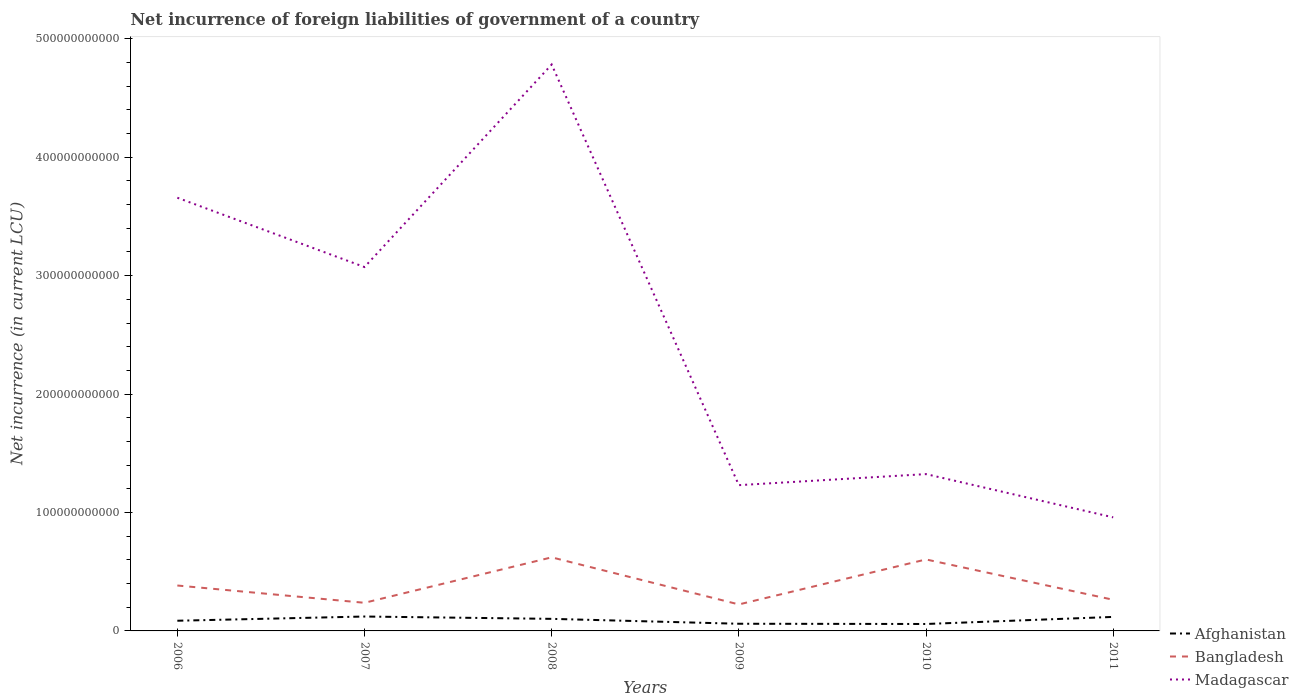Does the line corresponding to Madagascar intersect with the line corresponding to Bangladesh?
Your answer should be compact. No. Across all years, what is the maximum net incurrence of foreign liabilities in Afghanistan?
Offer a terse response. 5.86e+09. What is the total net incurrence of foreign liabilities in Bangladesh in the graph?
Provide a short and direct response. -3.94e+09. What is the difference between the highest and the second highest net incurrence of foreign liabilities in Madagascar?
Offer a terse response. 3.82e+11. How many lines are there?
Offer a terse response. 3. What is the difference between two consecutive major ticks on the Y-axis?
Your answer should be compact. 1.00e+11. Where does the legend appear in the graph?
Your response must be concise. Bottom right. How are the legend labels stacked?
Provide a short and direct response. Vertical. What is the title of the graph?
Ensure brevity in your answer.  Net incurrence of foreign liabilities of government of a country. Does "Uzbekistan" appear as one of the legend labels in the graph?
Your answer should be compact. No. What is the label or title of the X-axis?
Offer a very short reply. Years. What is the label or title of the Y-axis?
Keep it short and to the point. Net incurrence (in current LCU). What is the Net incurrence (in current LCU) of Afghanistan in 2006?
Your answer should be compact. 8.60e+09. What is the Net incurrence (in current LCU) in Bangladesh in 2006?
Your answer should be compact. 3.83e+1. What is the Net incurrence (in current LCU) of Madagascar in 2006?
Provide a succinct answer. 3.66e+11. What is the Net incurrence (in current LCU) in Afghanistan in 2007?
Ensure brevity in your answer.  1.22e+1. What is the Net incurrence (in current LCU) in Bangladesh in 2007?
Offer a terse response. 2.38e+1. What is the Net incurrence (in current LCU) in Madagascar in 2007?
Offer a very short reply. 3.07e+11. What is the Net incurrence (in current LCU) in Afghanistan in 2008?
Offer a terse response. 1.02e+1. What is the Net incurrence (in current LCU) of Bangladesh in 2008?
Offer a very short reply. 6.21e+1. What is the Net incurrence (in current LCU) in Madagascar in 2008?
Offer a very short reply. 4.78e+11. What is the Net incurrence (in current LCU) in Afghanistan in 2009?
Make the answer very short. 6.05e+09. What is the Net incurrence (in current LCU) in Bangladesh in 2009?
Your answer should be compact. 2.24e+1. What is the Net incurrence (in current LCU) of Madagascar in 2009?
Ensure brevity in your answer.  1.23e+11. What is the Net incurrence (in current LCU) of Afghanistan in 2010?
Give a very brief answer. 5.86e+09. What is the Net incurrence (in current LCU) of Bangladesh in 2010?
Provide a succinct answer. 6.04e+1. What is the Net incurrence (in current LCU) in Madagascar in 2010?
Make the answer very short. 1.32e+11. What is the Net incurrence (in current LCU) in Afghanistan in 2011?
Your answer should be compact. 1.18e+1. What is the Net incurrence (in current LCU) in Bangladesh in 2011?
Make the answer very short. 2.63e+1. What is the Net incurrence (in current LCU) of Madagascar in 2011?
Your response must be concise. 9.59e+1. Across all years, what is the maximum Net incurrence (in current LCU) of Afghanistan?
Give a very brief answer. 1.22e+1. Across all years, what is the maximum Net incurrence (in current LCU) in Bangladesh?
Offer a very short reply. 6.21e+1. Across all years, what is the maximum Net incurrence (in current LCU) in Madagascar?
Keep it short and to the point. 4.78e+11. Across all years, what is the minimum Net incurrence (in current LCU) in Afghanistan?
Your answer should be very brief. 5.86e+09. Across all years, what is the minimum Net incurrence (in current LCU) of Bangladesh?
Provide a succinct answer. 2.24e+1. Across all years, what is the minimum Net incurrence (in current LCU) of Madagascar?
Your answer should be compact. 9.59e+1. What is the total Net incurrence (in current LCU) of Afghanistan in the graph?
Your answer should be very brief. 5.47e+1. What is the total Net incurrence (in current LCU) of Bangladesh in the graph?
Your answer should be very brief. 2.33e+11. What is the total Net incurrence (in current LCU) of Madagascar in the graph?
Keep it short and to the point. 1.50e+12. What is the difference between the Net incurrence (in current LCU) of Afghanistan in 2006 and that in 2007?
Ensure brevity in your answer.  -3.56e+09. What is the difference between the Net incurrence (in current LCU) of Bangladesh in 2006 and that in 2007?
Your response must be concise. 1.46e+1. What is the difference between the Net incurrence (in current LCU) in Madagascar in 2006 and that in 2007?
Your response must be concise. 5.85e+1. What is the difference between the Net incurrence (in current LCU) of Afghanistan in 2006 and that in 2008?
Give a very brief answer. -1.59e+09. What is the difference between the Net incurrence (in current LCU) in Bangladesh in 2006 and that in 2008?
Give a very brief answer. -2.38e+1. What is the difference between the Net incurrence (in current LCU) in Madagascar in 2006 and that in 2008?
Your answer should be compact. -1.12e+11. What is the difference between the Net incurrence (in current LCU) of Afghanistan in 2006 and that in 2009?
Your answer should be compact. 2.55e+09. What is the difference between the Net incurrence (in current LCU) in Bangladesh in 2006 and that in 2009?
Make the answer very short. 1.60e+1. What is the difference between the Net incurrence (in current LCU) in Madagascar in 2006 and that in 2009?
Your response must be concise. 2.43e+11. What is the difference between the Net incurrence (in current LCU) in Afghanistan in 2006 and that in 2010?
Make the answer very short. 2.75e+09. What is the difference between the Net incurrence (in current LCU) in Bangladesh in 2006 and that in 2010?
Provide a short and direct response. -2.20e+1. What is the difference between the Net incurrence (in current LCU) in Madagascar in 2006 and that in 2010?
Make the answer very short. 2.33e+11. What is the difference between the Net incurrence (in current LCU) of Afghanistan in 2006 and that in 2011?
Keep it short and to the point. -3.23e+09. What is the difference between the Net incurrence (in current LCU) in Bangladesh in 2006 and that in 2011?
Provide a short and direct response. 1.20e+1. What is the difference between the Net incurrence (in current LCU) in Madagascar in 2006 and that in 2011?
Your answer should be very brief. 2.70e+11. What is the difference between the Net incurrence (in current LCU) in Afghanistan in 2007 and that in 2008?
Provide a succinct answer. 1.97e+09. What is the difference between the Net incurrence (in current LCU) in Bangladesh in 2007 and that in 2008?
Provide a short and direct response. -3.84e+1. What is the difference between the Net incurrence (in current LCU) of Madagascar in 2007 and that in 2008?
Offer a terse response. -1.71e+11. What is the difference between the Net incurrence (in current LCU) in Afghanistan in 2007 and that in 2009?
Offer a terse response. 6.11e+09. What is the difference between the Net incurrence (in current LCU) of Bangladesh in 2007 and that in 2009?
Your answer should be compact. 1.38e+09. What is the difference between the Net incurrence (in current LCU) in Madagascar in 2007 and that in 2009?
Make the answer very short. 1.84e+11. What is the difference between the Net incurrence (in current LCU) in Afghanistan in 2007 and that in 2010?
Your answer should be very brief. 6.31e+09. What is the difference between the Net incurrence (in current LCU) in Bangladesh in 2007 and that in 2010?
Offer a terse response. -3.66e+1. What is the difference between the Net incurrence (in current LCU) in Madagascar in 2007 and that in 2010?
Give a very brief answer. 1.75e+11. What is the difference between the Net incurrence (in current LCU) in Afghanistan in 2007 and that in 2011?
Provide a succinct answer. 3.28e+08. What is the difference between the Net incurrence (in current LCU) in Bangladesh in 2007 and that in 2011?
Offer a very short reply. -2.56e+09. What is the difference between the Net incurrence (in current LCU) of Madagascar in 2007 and that in 2011?
Provide a short and direct response. 2.11e+11. What is the difference between the Net incurrence (in current LCU) of Afghanistan in 2008 and that in 2009?
Your answer should be compact. 4.14e+09. What is the difference between the Net incurrence (in current LCU) in Bangladesh in 2008 and that in 2009?
Offer a terse response. 3.98e+1. What is the difference between the Net incurrence (in current LCU) in Madagascar in 2008 and that in 2009?
Offer a very short reply. 3.55e+11. What is the difference between the Net incurrence (in current LCU) in Afghanistan in 2008 and that in 2010?
Your answer should be very brief. 4.33e+09. What is the difference between the Net incurrence (in current LCU) of Bangladesh in 2008 and that in 2010?
Give a very brief answer. 1.78e+09. What is the difference between the Net incurrence (in current LCU) of Madagascar in 2008 and that in 2010?
Offer a very short reply. 3.46e+11. What is the difference between the Net incurrence (in current LCU) in Afghanistan in 2008 and that in 2011?
Provide a short and direct response. -1.64e+09. What is the difference between the Net incurrence (in current LCU) in Bangladesh in 2008 and that in 2011?
Your answer should be very brief. 3.58e+1. What is the difference between the Net incurrence (in current LCU) of Madagascar in 2008 and that in 2011?
Ensure brevity in your answer.  3.82e+11. What is the difference between the Net incurrence (in current LCU) in Afghanistan in 2009 and that in 2010?
Ensure brevity in your answer.  1.99e+08. What is the difference between the Net incurrence (in current LCU) of Bangladesh in 2009 and that in 2010?
Offer a terse response. -3.80e+1. What is the difference between the Net incurrence (in current LCU) in Madagascar in 2009 and that in 2010?
Ensure brevity in your answer.  -9.32e+09. What is the difference between the Net incurrence (in current LCU) in Afghanistan in 2009 and that in 2011?
Offer a very short reply. -5.78e+09. What is the difference between the Net incurrence (in current LCU) in Bangladesh in 2009 and that in 2011?
Offer a very short reply. -3.94e+09. What is the difference between the Net incurrence (in current LCU) of Madagascar in 2009 and that in 2011?
Keep it short and to the point. 2.72e+1. What is the difference between the Net incurrence (in current LCU) of Afghanistan in 2010 and that in 2011?
Provide a short and direct response. -5.98e+09. What is the difference between the Net incurrence (in current LCU) of Bangladesh in 2010 and that in 2011?
Your answer should be very brief. 3.40e+1. What is the difference between the Net incurrence (in current LCU) in Madagascar in 2010 and that in 2011?
Provide a succinct answer. 3.65e+1. What is the difference between the Net incurrence (in current LCU) of Afghanistan in 2006 and the Net incurrence (in current LCU) of Bangladesh in 2007?
Provide a succinct answer. -1.51e+1. What is the difference between the Net incurrence (in current LCU) in Afghanistan in 2006 and the Net incurrence (in current LCU) in Madagascar in 2007?
Your response must be concise. -2.99e+11. What is the difference between the Net incurrence (in current LCU) in Bangladesh in 2006 and the Net incurrence (in current LCU) in Madagascar in 2007?
Provide a succinct answer. -2.69e+11. What is the difference between the Net incurrence (in current LCU) in Afghanistan in 2006 and the Net incurrence (in current LCU) in Bangladesh in 2008?
Offer a terse response. -5.35e+1. What is the difference between the Net incurrence (in current LCU) of Afghanistan in 2006 and the Net incurrence (in current LCU) of Madagascar in 2008?
Provide a short and direct response. -4.70e+11. What is the difference between the Net incurrence (in current LCU) of Bangladesh in 2006 and the Net incurrence (in current LCU) of Madagascar in 2008?
Offer a terse response. -4.40e+11. What is the difference between the Net incurrence (in current LCU) of Afghanistan in 2006 and the Net incurrence (in current LCU) of Bangladesh in 2009?
Offer a very short reply. -1.38e+1. What is the difference between the Net incurrence (in current LCU) of Afghanistan in 2006 and the Net incurrence (in current LCU) of Madagascar in 2009?
Offer a terse response. -1.14e+11. What is the difference between the Net incurrence (in current LCU) in Bangladesh in 2006 and the Net incurrence (in current LCU) in Madagascar in 2009?
Offer a terse response. -8.47e+1. What is the difference between the Net incurrence (in current LCU) in Afghanistan in 2006 and the Net incurrence (in current LCU) in Bangladesh in 2010?
Your answer should be compact. -5.18e+1. What is the difference between the Net incurrence (in current LCU) of Afghanistan in 2006 and the Net incurrence (in current LCU) of Madagascar in 2010?
Offer a very short reply. -1.24e+11. What is the difference between the Net incurrence (in current LCU) of Bangladesh in 2006 and the Net incurrence (in current LCU) of Madagascar in 2010?
Keep it short and to the point. -9.41e+1. What is the difference between the Net incurrence (in current LCU) in Afghanistan in 2006 and the Net incurrence (in current LCU) in Bangladesh in 2011?
Your response must be concise. -1.77e+1. What is the difference between the Net incurrence (in current LCU) of Afghanistan in 2006 and the Net incurrence (in current LCU) of Madagascar in 2011?
Provide a succinct answer. -8.73e+1. What is the difference between the Net incurrence (in current LCU) of Bangladesh in 2006 and the Net incurrence (in current LCU) of Madagascar in 2011?
Your response must be concise. -5.76e+1. What is the difference between the Net incurrence (in current LCU) in Afghanistan in 2007 and the Net incurrence (in current LCU) in Bangladesh in 2008?
Your answer should be compact. -5.00e+1. What is the difference between the Net incurrence (in current LCU) in Afghanistan in 2007 and the Net incurrence (in current LCU) in Madagascar in 2008?
Make the answer very short. -4.66e+11. What is the difference between the Net incurrence (in current LCU) in Bangladesh in 2007 and the Net incurrence (in current LCU) in Madagascar in 2008?
Keep it short and to the point. -4.55e+11. What is the difference between the Net incurrence (in current LCU) in Afghanistan in 2007 and the Net incurrence (in current LCU) in Bangladesh in 2009?
Provide a succinct answer. -1.02e+1. What is the difference between the Net incurrence (in current LCU) of Afghanistan in 2007 and the Net incurrence (in current LCU) of Madagascar in 2009?
Offer a terse response. -1.11e+11. What is the difference between the Net incurrence (in current LCU) of Bangladesh in 2007 and the Net incurrence (in current LCU) of Madagascar in 2009?
Provide a short and direct response. -9.93e+1. What is the difference between the Net incurrence (in current LCU) of Afghanistan in 2007 and the Net incurrence (in current LCU) of Bangladesh in 2010?
Keep it short and to the point. -4.82e+1. What is the difference between the Net incurrence (in current LCU) of Afghanistan in 2007 and the Net incurrence (in current LCU) of Madagascar in 2010?
Give a very brief answer. -1.20e+11. What is the difference between the Net incurrence (in current LCU) of Bangladesh in 2007 and the Net incurrence (in current LCU) of Madagascar in 2010?
Provide a short and direct response. -1.09e+11. What is the difference between the Net incurrence (in current LCU) of Afghanistan in 2007 and the Net incurrence (in current LCU) of Bangladesh in 2011?
Provide a short and direct response. -1.41e+1. What is the difference between the Net incurrence (in current LCU) in Afghanistan in 2007 and the Net incurrence (in current LCU) in Madagascar in 2011?
Give a very brief answer. -8.37e+1. What is the difference between the Net incurrence (in current LCU) in Bangladesh in 2007 and the Net incurrence (in current LCU) in Madagascar in 2011?
Your answer should be very brief. -7.21e+1. What is the difference between the Net incurrence (in current LCU) in Afghanistan in 2008 and the Net incurrence (in current LCU) in Bangladesh in 2009?
Make the answer very short. -1.22e+1. What is the difference between the Net incurrence (in current LCU) of Afghanistan in 2008 and the Net incurrence (in current LCU) of Madagascar in 2009?
Provide a succinct answer. -1.13e+11. What is the difference between the Net incurrence (in current LCU) of Bangladesh in 2008 and the Net incurrence (in current LCU) of Madagascar in 2009?
Offer a terse response. -6.10e+1. What is the difference between the Net incurrence (in current LCU) in Afghanistan in 2008 and the Net incurrence (in current LCU) in Bangladesh in 2010?
Ensure brevity in your answer.  -5.02e+1. What is the difference between the Net incurrence (in current LCU) of Afghanistan in 2008 and the Net incurrence (in current LCU) of Madagascar in 2010?
Your response must be concise. -1.22e+11. What is the difference between the Net incurrence (in current LCU) of Bangladesh in 2008 and the Net incurrence (in current LCU) of Madagascar in 2010?
Your response must be concise. -7.03e+1. What is the difference between the Net incurrence (in current LCU) in Afghanistan in 2008 and the Net incurrence (in current LCU) in Bangladesh in 2011?
Your response must be concise. -1.61e+1. What is the difference between the Net incurrence (in current LCU) of Afghanistan in 2008 and the Net incurrence (in current LCU) of Madagascar in 2011?
Ensure brevity in your answer.  -8.57e+1. What is the difference between the Net incurrence (in current LCU) in Bangladesh in 2008 and the Net incurrence (in current LCU) in Madagascar in 2011?
Your answer should be very brief. -3.38e+1. What is the difference between the Net incurrence (in current LCU) in Afghanistan in 2009 and the Net incurrence (in current LCU) in Bangladesh in 2010?
Your answer should be compact. -5.43e+1. What is the difference between the Net incurrence (in current LCU) in Afghanistan in 2009 and the Net incurrence (in current LCU) in Madagascar in 2010?
Offer a very short reply. -1.26e+11. What is the difference between the Net incurrence (in current LCU) of Bangladesh in 2009 and the Net incurrence (in current LCU) of Madagascar in 2010?
Ensure brevity in your answer.  -1.10e+11. What is the difference between the Net incurrence (in current LCU) of Afghanistan in 2009 and the Net incurrence (in current LCU) of Bangladesh in 2011?
Offer a terse response. -2.03e+1. What is the difference between the Net incurrence (in current LCU) in Afghanistan in 2009 and the Net incurrence (in current LCU) in Madagascar in 2011?
Your response must be concise. -8.98e+1. What is the difference between the Net incurrence (in current LCU) of Bangladesh in 2009 and the Net incurrence (in current LCU) of Madagascar in 2011?
Your answer should be compact. -7.35e+1. What is the difference between the Net incurrence (in current LCU) in Afghanistan in 2010 and the Net incurrence (in current LCU) in Bangladesh in 2011?
Make the answer very short. -2.05e+1. What is the difference between the Net incurrence (in current LCU) in Afghanistan in 2010 and the Net incurrence (in current LCU) in Madagascar in 2011?
Offer a terse response. -9.00e+1. What is the difference between the Net incurrence (in current LCU) in Bangladesh in 2010 and the Net incurrence (in current LCU) in Madagascar in 2011?
Provide a short and direct response. -3.55e+1. What is the average Net incurrence (in current LCU) in Afghanistan per year?
Keep it short and to the point. 9.12e+09. What is the average Net incurrence (in current LCU) in Bangladesh per year?
Offer a very short reply. 3.89e+1. What is the average Net incurrence (in current LCU) of Madagascar per year?
Your answer should be very brief. 2.50e+11. In the year 2006, what is the difference between the Net incurrence (in current LCU) in Afghanistan and Net incurrence (in current LCU) in Bangladesh?
Your answer should be compact. -2.97e+1. In the year 2006, what is the difference between the Net incurrence (in current LCU) of Afghanistan and Net incurrence (in current LCU) of Madagascar?
Your answer should be very brief. -3.57e+11. In the year 2006, what is the difference between the Net incurrence (in current LCU) in Bangladesh and Net incurrence (in current LCU) in Madagascar?
Your answer should be very brief. -3.27e+11. In the year 2007, what is the difference between the Net incurrence (in current LCU) of Afghanistan and Net incurrence (in current LCU) of Bangladesh?
Make the answer very short. -1.16e+1. In the year 2007, what is the difference between the Net incurrence (in current LCU) in Afghanistan and Net incurrence (in current LCU) in Madagascar?
Offer a terse response. -2.95e+11. In the year 2007, what is the difference between the Net incurrence (in current LCU) in Bangladesh and Net incurrence (in current LCU) in Madagascar?
Provide a succinct answer. -2.84e+11. In the year 2008, what is the difference between the Net incurrence (in current LCU) of Afghanistan and Net incurrence (in current LCU) of Bangladesh?
Provide a succinct answer. -5.19e+1. In the year 2008, what is the difference between the Net incurrence (in current LCU) in Afghanistan and Net incurrence (in current LCU) in Madagascar?
Provide a short and direct response. -4.68e+11. In the year 2008, what is the difference between the Net incurrence (in current LCU) of Bangladesh and Net incurrence (in current LCU) of Madagascar?
Give a very brief answer. -4.16e+11. In the year 2009, what is the difference between the Net incurrence (in current LCU) in Afghanistan and Net incurrence (in current LCU) in Bangladesh?
Make the answer very short. -1.63e+1. In the year 2009, what is the difference between the Net incurrence (in current LCU) in Afghanistan and Net incurrence (in current LCU) in Madagascar?
Provide a short and direct response. -1.17e+11. In the year 2009, what is the difference between the Net incurrence (in current LCU) in Bangladesh and Net incurrence (in current LCU) in Madagascar?
Your response must be concise. -1.01e+11. In the year 2010, what is the difference between the Net incurrence (in current LCU) of Afghanistan and Net incurrence (in current LCU) of Bangladesh?
Offer a very short reply. -5.45e+1. In the year 2010, what is the difference between the Net incurrence (in current LCU) in Afghanistan and Net incurrence (in current LCU) in Madagascar?
Ensure brevity in your answer.  -1.27e+11. In the year 2010, what is the difference between the Net incurrence (in current LCU) in Bangladesh and Net incurrence (in current LCU) in Madagascar?
Provide a short and direct response. -7.21e+1. In the year 2011, what is the difference between the Net incurrence (in current LCU) in Afghanistan and Net incurrence (in current LCU) in Bangladesh?
Ensure brevity in your answer.  -1.45e+1. In the year 2011, what is the difference between the Net incurrence (in current LCU) in Afghanistan and Net incurrence (in current LCU) in Madagascar?
Offer a very short reply. -8.41e+1. In the year 2011, what is the difference between the Net incurrence (in current LCU) of Bangladesh and Net incurrence (in current LCU) of Madagascar?
Provide a succinct answer. -6.96e+1. What is the ratio of the Net incurrence (in current LCU) in Afghanistan in 2006 to that in 2007?
Give a very brief answer. 0.71. What is the ratio of the Net incurrence (in current LCU) in Bangladesh in 2006 to that in 2007?
Keep it short and to the point. 1.61. What is the ratio of the Net incurrence (in current LCU) of Madagascar in 2006 to that in 2007?
Your answer should be very brief. 1.19. What is the ratio of the Net incurrence (in current LCU) in Afghanistan in 2006 to that in 2008?
Offer a very short reply. 0.84. What is the ratio of the Net incurrence (in current LCU) of Bangladesh in 2006 to that in 2008?
Give a very brief answer. 0.62. What is the ratio of the Net incurrence (in current LCU) of Madagascar in 2006 to that in 2008?
Ensure brevity in your answer.  0.76. What is the ratio of the Net incurrence (in current LCU) of Afghanistan in 2006 to that in 2009?
Provide a succinct answer. 1.42. What is the ratio of the Net incurrence (in current LCU) in Bangladesh in 2006 to that in 2009?
Make the answer very short. 1.71. What is the ratio of the Net incurrence (in current LCU) of Madagascar in 2006 to that in 2009?
Give a very brief answer. 2.97. What is the ratio of the Net incurrence (in current LCU) of Afghanistan in 2006 to that in 2010?
Offer a very short reply. 1.47. What is the ratio of the Net incurrence (in current LCU) in Bangladesh in 2006 to that in 2010?
Provide a succinct answer. 0.64. What is the ratio of the Net incurrence (in current LCU) of Madagascar in 2006 to that in 2010?
Offer a very short reply. 2.76. What is the ratio of the Net incurrence (in current LCU) in Afghanistan in 2006 to that in 2011?
Make the answer very short. 0.73. What is the ratio of the Net incurrence (in current LCU) in Bangladesh in 2006 to that in 2011?
Your answer should be very brief. 1.46. What is the ratio of the Net incurrence (in current LCU) of Madagascar in 2006 to that in 2011?
Make the answer very short. 3.81. What is the ratio of the Net incurrence (in current LCU) in Afghanistan in 2007 to that in 2008?
Your answer should be very brief. 1.19. What is the ratio of the Net incurrence (in current LCU) in Bangladesh in 2007 to that in 2008?
Make the answer very short. 0.38. What is the ratio of the Net incurrence (in current LCU) of Madagascar in 2007 to that in 2008?
Your answer should be compact. 0.64. What is the ratio of the Net incurrence (in current LCU) in Afghanistan in 2007 to that in 2009?
Your response must be concise. 2.01. What is the ratio of the Net incurrence (in current LCU) of Bangladesh in 2007 to that in 2009?
Offer a terse response. 1.06. What is the ratio of the Net incurrence (in current LCU) of Madagascar in 2007 to that in 2009?
Provide a short and direct response. 2.5. What is the ratio of the Net incurrence (in current LCU) in Afghanistan in 2007 to that in 2010?
Provide a succinct answer. 2.08. What is the ratio of the Net incurrence (in current LCU) of Bangladesh in 2007 to that in 2010?
Offer a very short reply. 0.39. What is the ratio of the Net incurrence (in current LCU) in Madagascar in 2007 to that in 2010?
Your answer should be very brief. 2.32. What is the ratio of the Net incurrence (in current LCU) in Afghanistan in 2007 to that in 2011?
Your answer should be compact. 1.03. What is the ratio of the Net incurrence (in current LCU) in Bangladesh in 2007 to that in 2011?
Provide a succinct answer. 0.9. What is the ratio of the Net incurrence (in current LCU) in Madagascar in 2007 to that in 2011?
Your answer should be compact. 3.2. What is the ratio of the Net incurrence (in current LCU) in Afghanistan in 2008 to that in 2009?
Offer a terse response. 1.68. What is the ratio of the Net incurrence (in current LCU) of Bangladesh in 2008 to that in 2009?
Offer a very short reply. 2.78. What is the ratio of the Net incurrence (in current LCU) in Madagascar in 2008 to that in 2009?
Your response must be concise. 3.89. What is the ratio of the Net incurrence (in current LCU) of Afghanistan in 2008 to that in 2010?
Your response must be concise. 1.74. What is the ratio of the Net incurrence (in current LCU) in Bangladesh in 2008 to that in 2010?
Make the answer very short. 1.03. What is the ratio of the Net incurrence (in current LCU) in Madagascar in 2008 to that in 2010?
Offer a terse response. 3.61. What is the ratio of the Net incurrence (in current LCU) in Afghanistan in 2008 to that in 2011?
Your response must be concise. 0.86. What is the ratio of the Net incurrence (in current LCU) in Bangladesh in 2008 to that in 2011?
Provide a succinct answer. 2.36. What is the ratio of the Net incurrence (in current LCU) of Madagascar in 2008 to that in 2011?
Keep it short and to the point. 4.99. What is the ratio of the Net incurrence (in current LCU) of Afghanistan in 2009 to that in 2010?
Your answer should be very brief. 1.03. What is the ratio of the Net incurrence (in current LCU) of Bangladesh in 2009 to that in 2010?
Make the answer very short. 0.37. What is the ratio of the Net incurrence (in current LCU) of Madagascar in 2009 to that in 2010?
Your response must be concise. 0.93. What is the ratio of the Net incurrence (in current LCU) of Afghanistan in 2009 to that in 2011?
Ensure brevity in your answer.  0.51. What is the ratio of the Net incurrence (in current LCU) in Bangladesh in 2009 to that in 2011?
Give a very brief answer. 0.85. What is the ratio of the Net incurrence (in current LCU) of Madagascar in 2009 to that in 2011?
Give a very brief answer. 1.28. What is the ratio of the Net incurrence (in current LCU) of Afghanistan in 2010 to that in 2011?
Give a very brief answer. 0.49. What is the ratio of the Net incurrence (in current LCU) in Bangladesh in 2010 to that in 2011?
Provide a short and direct response. 2.29. What is the ratio of the Net incurrence (in current LCU) of Madagascar in 2010 to that in 2011?
Your answer should be compact. 1.38. What is the difference between the highest and the second highest Net incurrence (in current LCU) in Afghanistan?
Provide a succinct answer. 3.28e+08. What is the difference between the highest and the second highest Net incurrence (in current LCU) of Bangladesh?
Make the answer very short. 1.78e+09. What is the difference between the highest and the second highest Net incurrence (in current LCU) in Madagascar?
Offer a terse response. 1.12e+11. What is the difference between the highest and the lowest Net incurrence (in current LCU) in Afghanistan?
Keep it short and to the point. 6.31e+09. What is the difference between the highest and the lowest Net incurrence (in current LCU) in Bangladesh?
Your response must be concise. 3.98e+1. What is the difference between the highest and the lowest Net incurrence (in current LCU) in Madagascar?
Offer a terse response. 3.82e+11. 